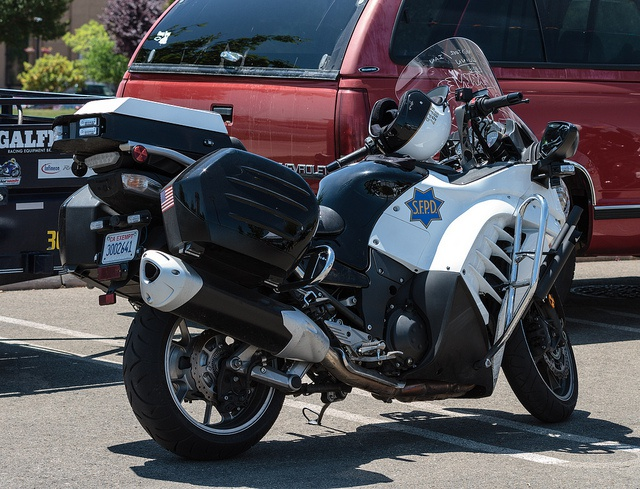Describe the objects in this image and their specific colors. I can see motorcycle in black, gray, and darkgray tones, car in black, maroon, blue, and brown tones, and car in black, gray, and blue tones in this image. 